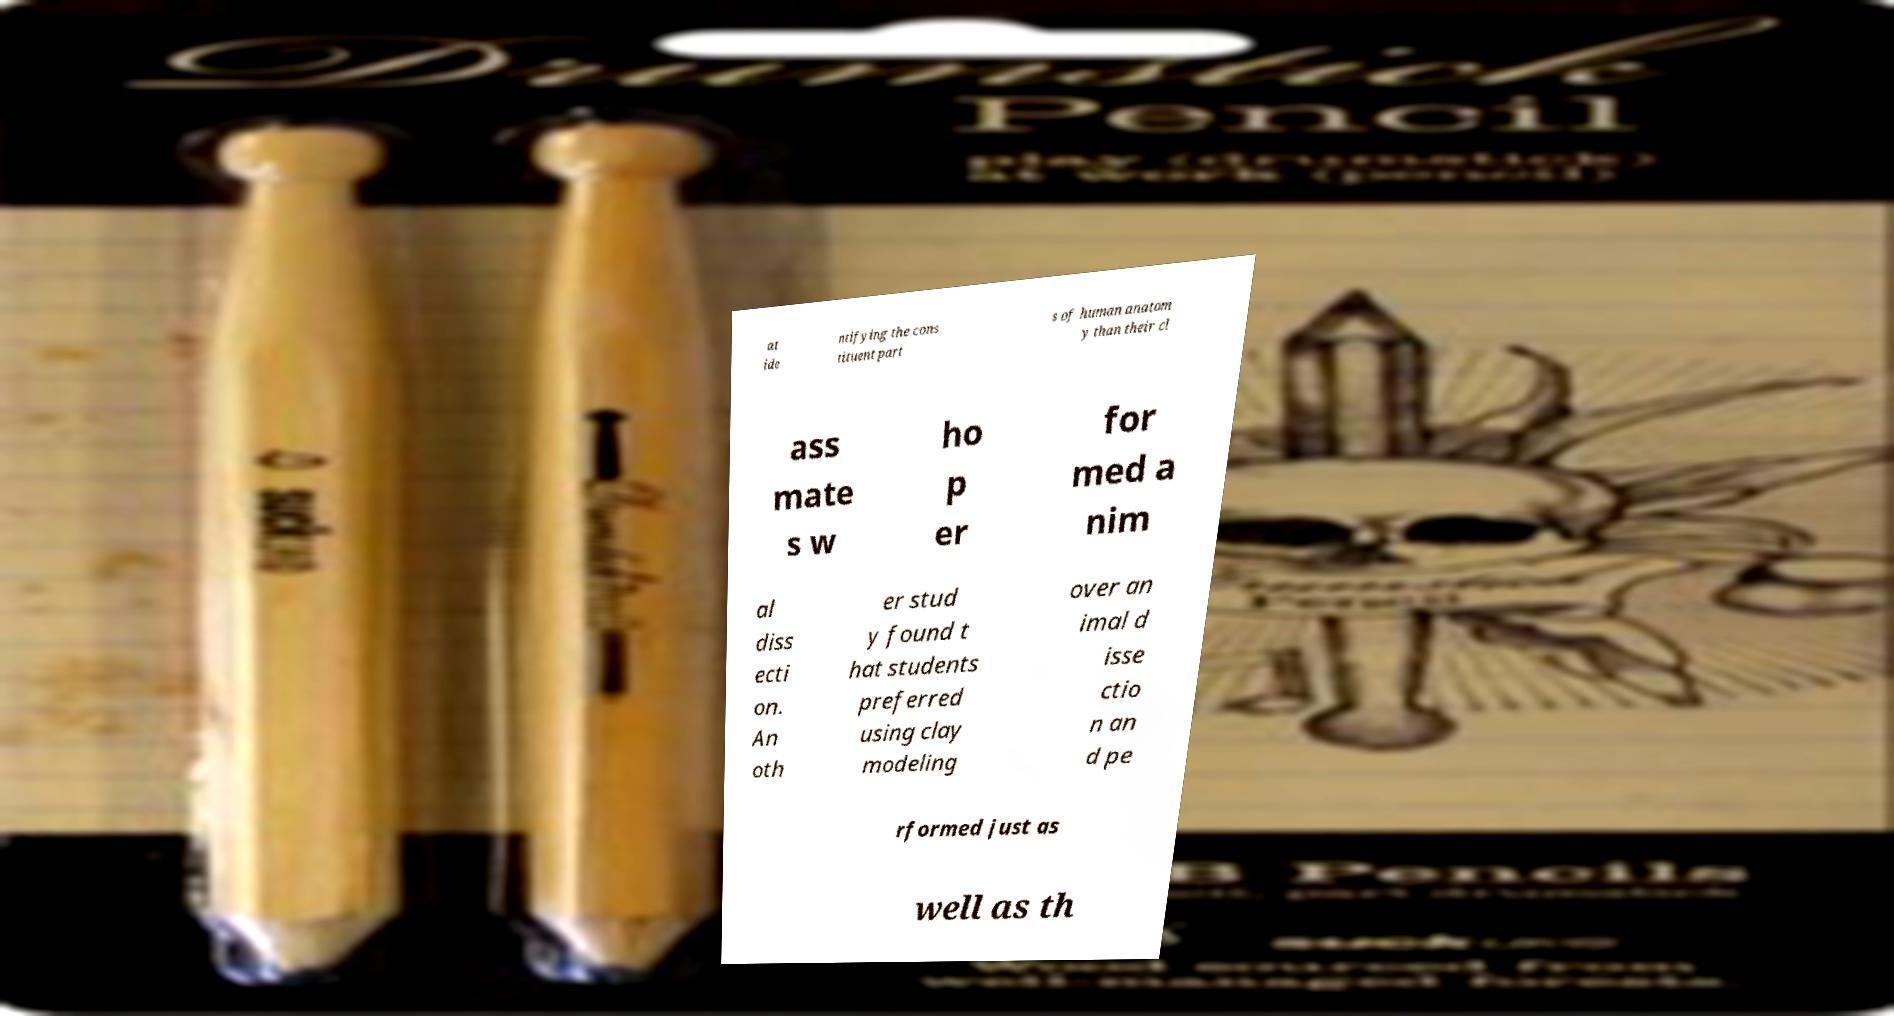What messages or text are displayed in this image? I need them in a readable, typed format. at ide ntifying the cons tituent part s of human anatom y than their cl ass mate s w ho p er for med a nim al diss ecti on. An oth er stud y found t hat students preferred using clay modeling over an imal d isse ctio n an d pe rformed just as well as th 